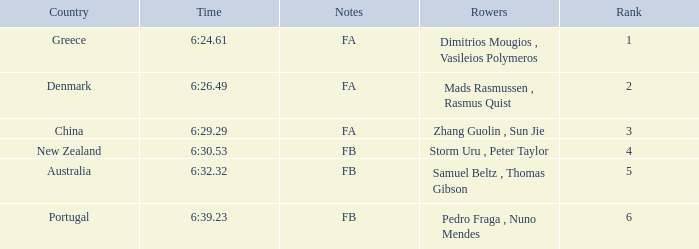What is the rank of the time of 6:30.53? 1.0. 